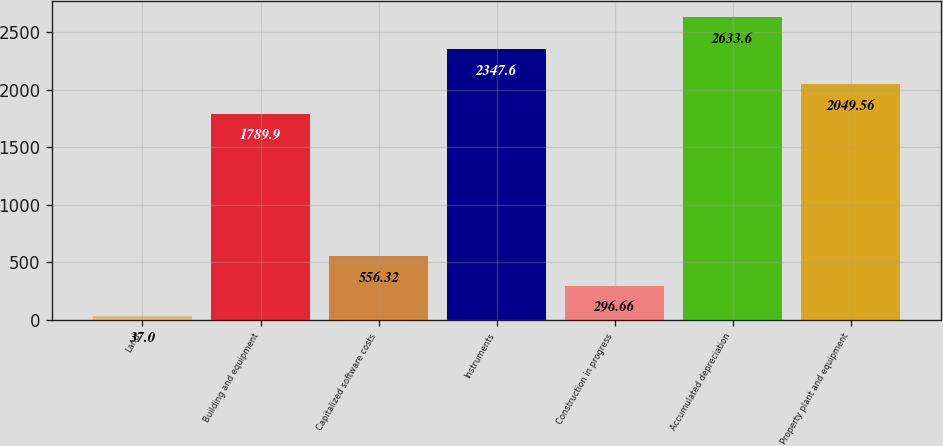Convert chart. <chart><loc_0><loc_0><loc_500><loc_500><bar_chart><fcel>Land<fcel>Building and equipment<fcel>Capitalized software costs<fcel>Instruments<fcel>Construction in progress<fcel>Accumulated depreciation<fcel>Property plant and equipment<nl><fcel>37<fcel>1789.9<fcel>556.32<fcel>2347.6<fcel>296.66<fcel>2633.6<fcel>2049.56<nl></chart> 